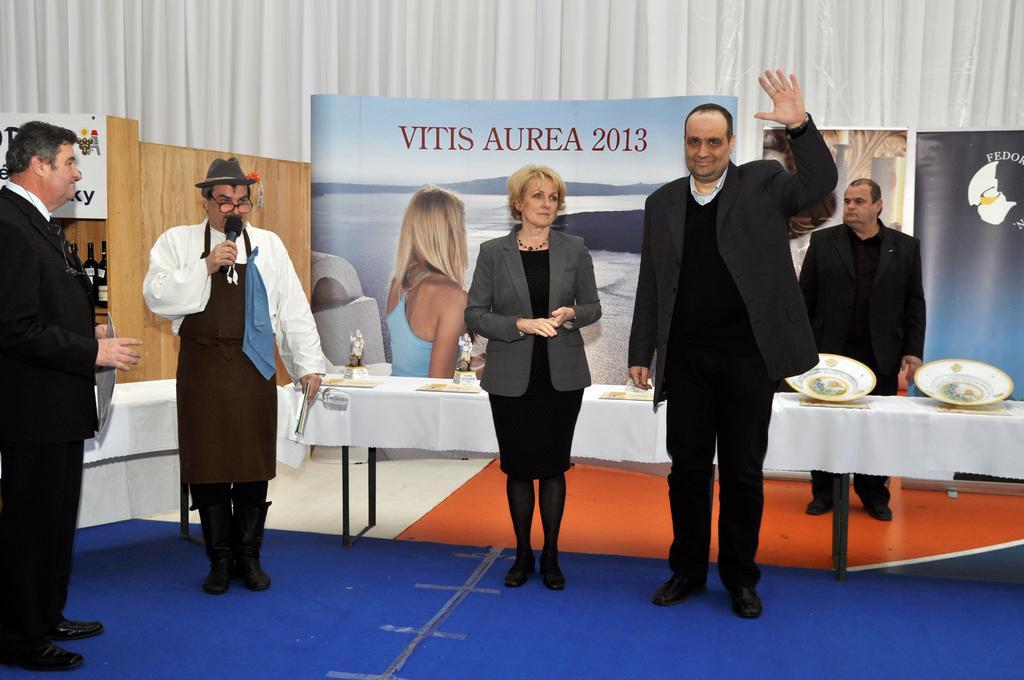Could you give a brief overview of what you see in this image? In this image there are few people in which one of them holds a microphone and an object, there are a few bottles and plates on the table and the table is covered with cloth, a curtain, a few posters and bottles in the shelf. 